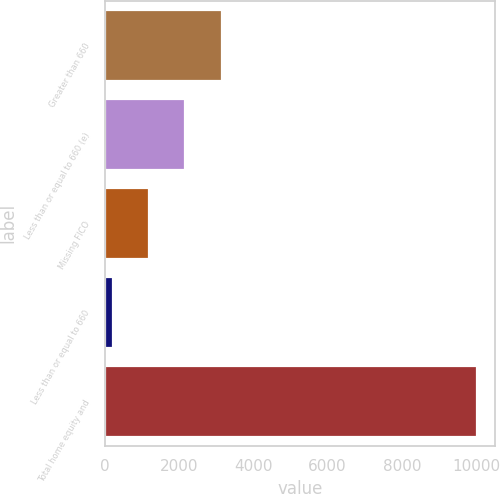Convert chart. <chart><loc_0><loc_0><loc_500><loc_500><bar_chart><fcel>Greater than 660<fcel>Less than or equal to 660 (e)<fcel>Missing FICO<fcel>Less than or equal to 660<fcel>Total home equity and<nl><fcel>3146.3<fcel>2164.2<fcel>1182.1<fcel>200<fcel>10021<nl></chart> 